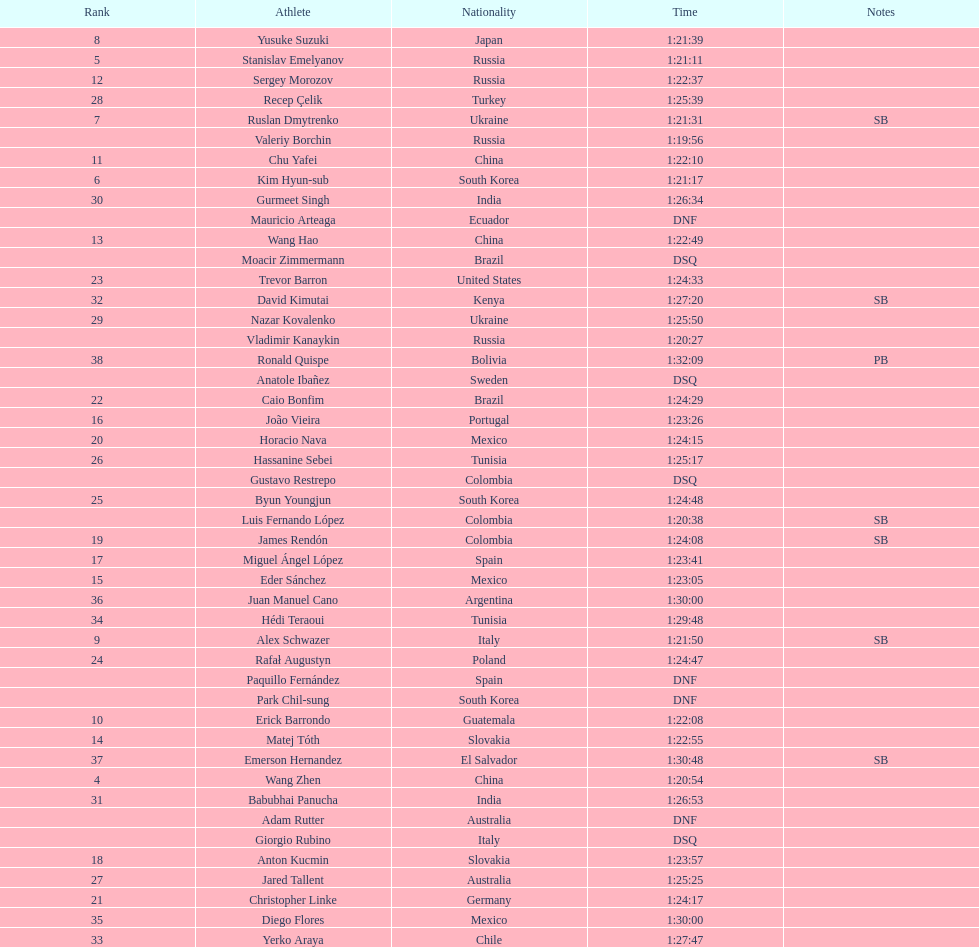Which competitor was ranked first? Valeriy Borchin. 